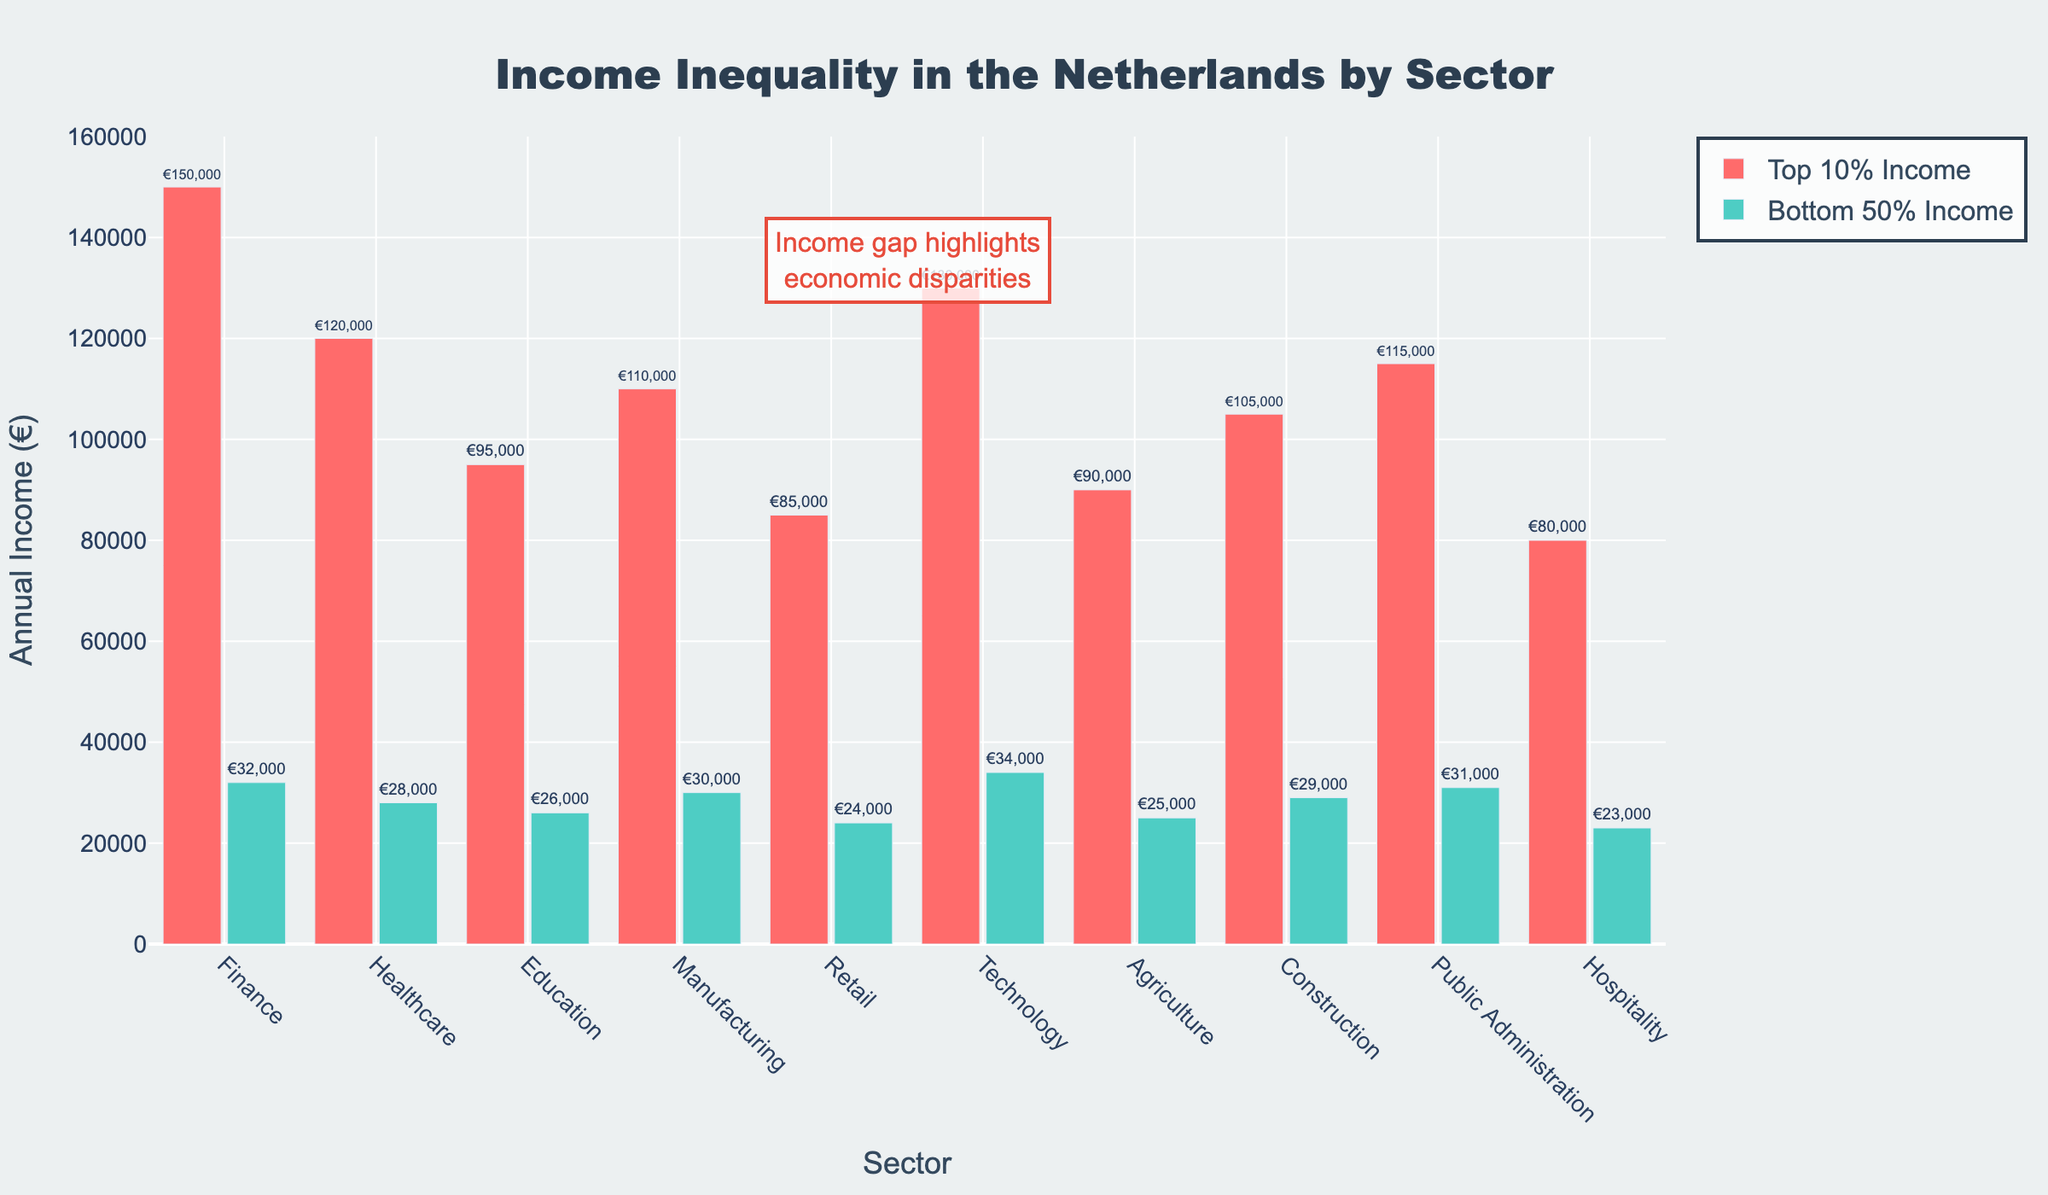Which sector has the highest income for the top 10%? The "Top 10% Income" bar is highest for the Finance sector, as indicated by the length and height of the red bar.
Answer: Finance Which sector has the least difference between the top 10% and bottom 50% incomes? The least difference can be determined by calculating the difference between the top 10% and bottom 50% incomes for each sector, and finding the smallest value. For Retail, €85,000 - €24,000 = €61,000; for Hospitality, €80,000 - €23,000 = €57,000. The smallest difference is in the Hospitality sector.
Answer: Hospitality Which sector shows the smallest income for the bottom 50%? The "Bottom 50% Income" bar is the shortest for the Hospitality sector, indicated by the height of the green bar.
Answer: Hospitality What is the average income of the top 10% across all sectors? Sum the top 10% incomes: €150,000 + €120,000 + €95,000 + €110,000 + €85,000 + €130,000 + €90,000 + €105,000 + €115,000 + €80,000 = €1,080,000. Divide by the number of sectors (10): €1,080,000 / 10 = €108,000
Answer: €108,000 Which sector has the widest gap between top 10% and bottom 50% incomes? Calculate the income gap for each sector. For Finance: €150,000 - €32,000 = €118,000; Healthcare: €120,000 - €28,000 = €92,000; Education: €95,000 - €26,000 = €69,000; Manufacturing: €110,000 - €30,000 = €80,000; Retail: €85,000 - €24,000 = €61,000; Technology: €130,000 - €34,000 = €96,000; Agriculture: €90,000 - €25,000 = €65,000; Construction: €105,000 - €29,000 = €76,000; Public Administration: €115,000 - €31,000 = €84,000; Hospitality: €80,000 - €23,000 = €57,000. The Finance sector has the widest gap: €118,000.
Answer: Finance What is the combined income for the top 10% and bottom 50% in the Technology sector? Top 10% income in Technology is €130,000, and bottom 50% income is €34,000. Summing these values: €130,000 + €34,000 = €164,000
Answer: €164,000 Compare the top 10% income between Healthcare and Education sectors. Which one is higher, and by how much? The top 10% income is €120,000 for Healthcare and €95,000 for Education. The difference is €120,000 - €95,000 = €25,000, meaning Healthcare is higher by €25,000.
Answer: Healthcare by €25,000 What percentage of the top 10% income in the Finance sector is the bottom 50% income in the same sector? The top 10% income in Finance is €150,000, and the bottom 50% income is €32,000. The percentage is (€32,000 / €150,000) * 100 = 21.33%
Answer: 21.33% How does the income disparity between the top 10% and bottom 50% in Manufacturing compare to that in Public Administration? The income disparity in Manufacturing is €110,000 - €30,000 = €80,000, whereas in Public Administration it is €115,000 - €31,000 = €84,000. The disparity is larger in Public Administration by €84,000 - €80,000 = €4,000.
Answer: Public Administration by €4,000 